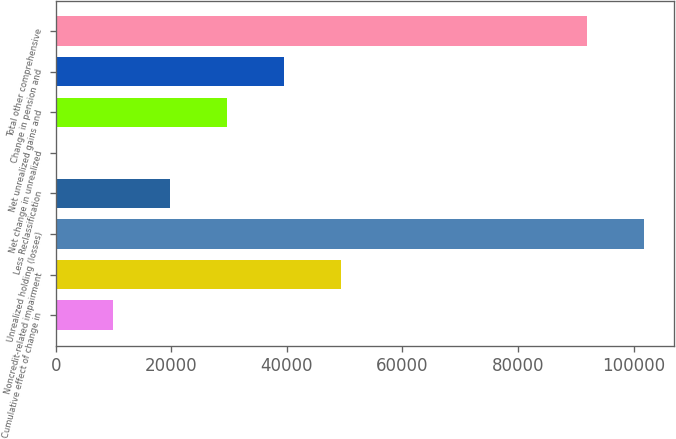Convert chart. <chart><loc_0><loc_0><loc_500><loc_500><bar_chart><fcel>Cumulative effect of change in<fcel>Noncredit-related impairment<fcel>Unrealized holding (losses)<fcel>Less Reclassification<fcel>Net change in unrealized<fcel>Net unrealized gains and<fcel>Change in pension and<fcel>Total other comprehensive<nl><fcel>9870.5<fcel>49340.5<fcel>101866<fcel>19738<fcel>3<fcel>29605.5<fcel>39473<fcel>91998<nl></chart> 